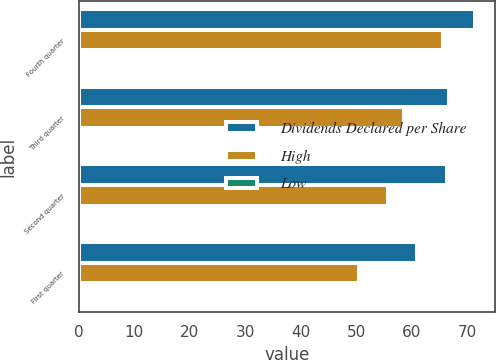<chart> <loc_0><loc_0><loc_500><loc_500><stacked_bar_chart><ecel><fcel>Fourth quarter<fcel>Third quarter<fcel>Second quarter<fcel>First quarter<nl><fcel>Dividends Declared per Share<fcel>71.53<fcel>66.8<fcel>66.33<fcel>61<nl><fcel>High<fcel>65.59<fcel>58.57<fcel>55.8<fcel>50.49<nl><fcel>Low<fcel>0.21<fcel>0.16<fcel>0.16<fcel>0.16<nl></chart> 